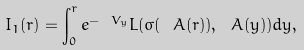<formula> <loc_0><loc_0><loc_500><loc_500>I _ { 1 } ( r ) = \int _ { 0 } ^ { r } e ^ { - \ V _ { y } } L ( \sigma ( \ A ( r ) ) , \ A ( y ) ) d y , \\</formula> 